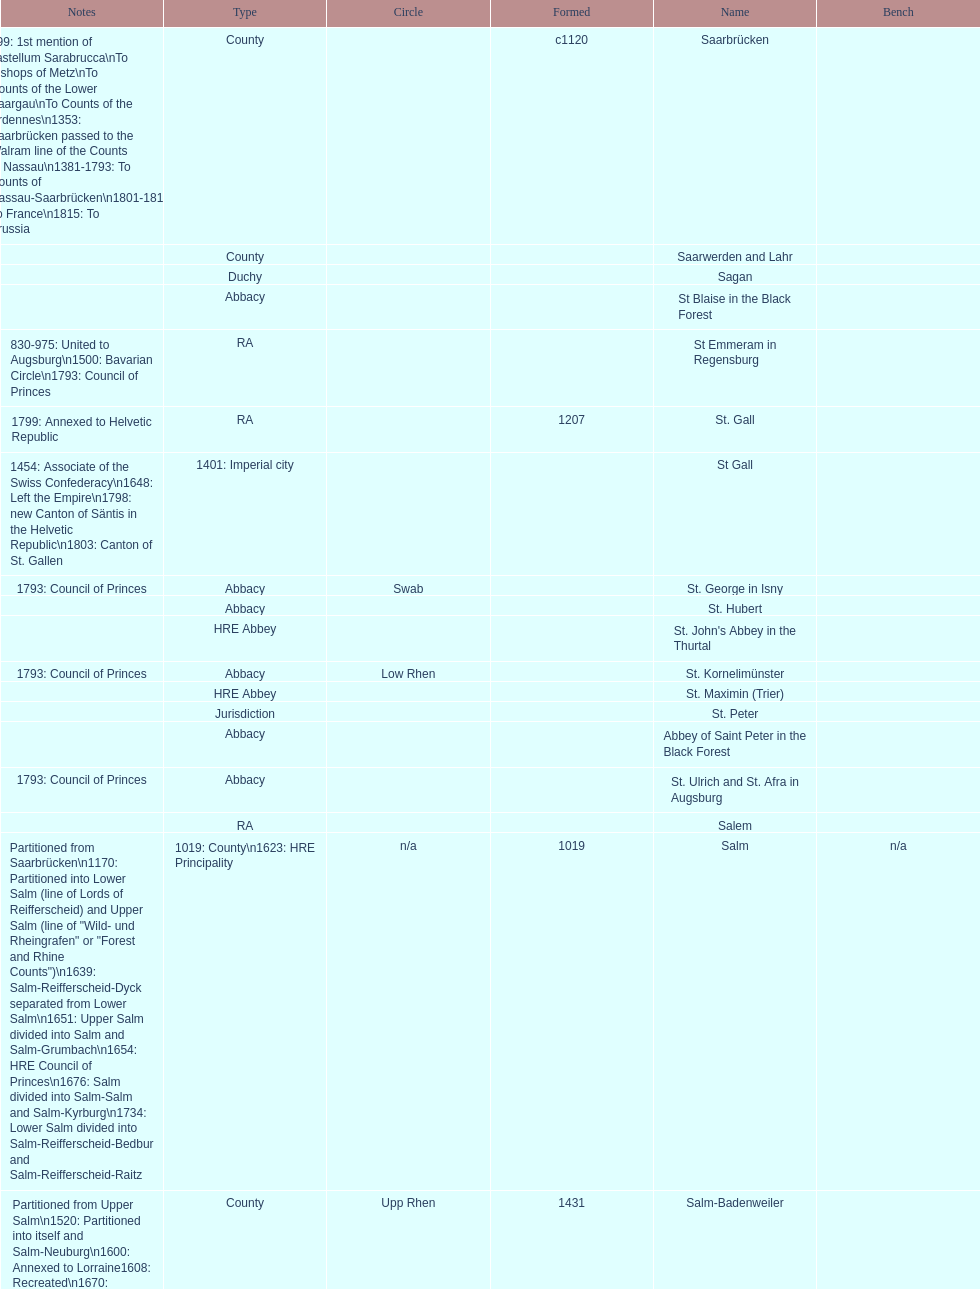How many states were of the same type as stuhlingen? 3. 